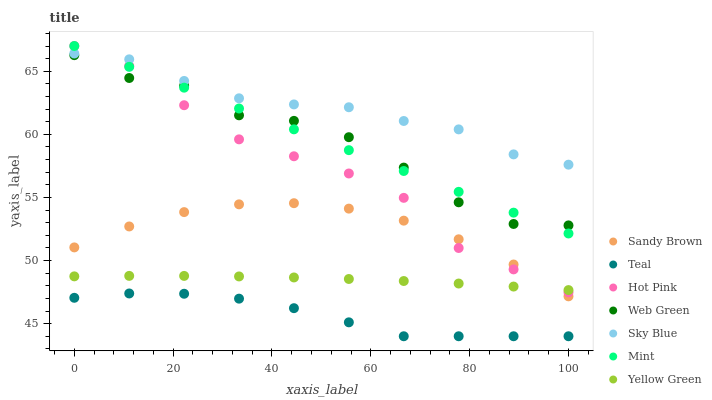Does Teal have the minimum area under the curve?
Answer yes or no. Yes. Does Sky Blue have the maximum area under the curve?
Answer yes or no. Yes. Does Mint have the minimum area under the curve?
Answer yes or no. No. Does Mint have the maximum area under the curve?
Answer yes or no. No. Is Mint the smoothest?
Answer yes or no. Yes. Is Web Green the roughest?
Answer yes or no. Yes. Is Hot Pink the smoothest?
Answer yes or no. No. Is Hot Pink the roughest?
Answer yes or no. No. Does Teal have the lowest value?
Answer yes or no. Yes. Does Mint have the lowest value?
Answer yes or no. No. Does Hot Pink have the highest value?
Answer yes or no. Yes. Does Web Green have the highest value?
Answer yes or no. No. Is Teal less than Hot Pink?
Answer yes or no. Yes. Is Sky Blue greater than Web Green?
Answer yes or no. Yes. Does Web Green intersect Mint?
Answer yes or no. Yes. Is Web Green less than Mint?
Answer yes or no. No. Is Web Green greater than Mint?
Answer yes or no. No. Does Teal intersect Hot Pink?
Answer yes or no. No. 